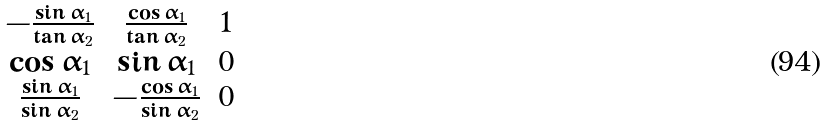Convert formula to latex. <formula><loc_0><loc_0><loc_500><loc_500>\begin{matrix} - \frac { \sin \alpha _ { 1 } } { \tan \alpha _ { 2 } } & \frac { \cos \alpha _ { 1 } } { \tan \alpha _ { 2 } } & 1 \\ \cos \alpha _ { 1 } & \sin \alpha _ { 1 } & 0 \\ \frac { \sin \alpha _ { 1 } } { \sin \alpha _ { 2 } } & - \frac { \cos \alpha _ { 1 } } { \sin \alpha _ { 2 } } & 0 \end{matrix}</formula> 